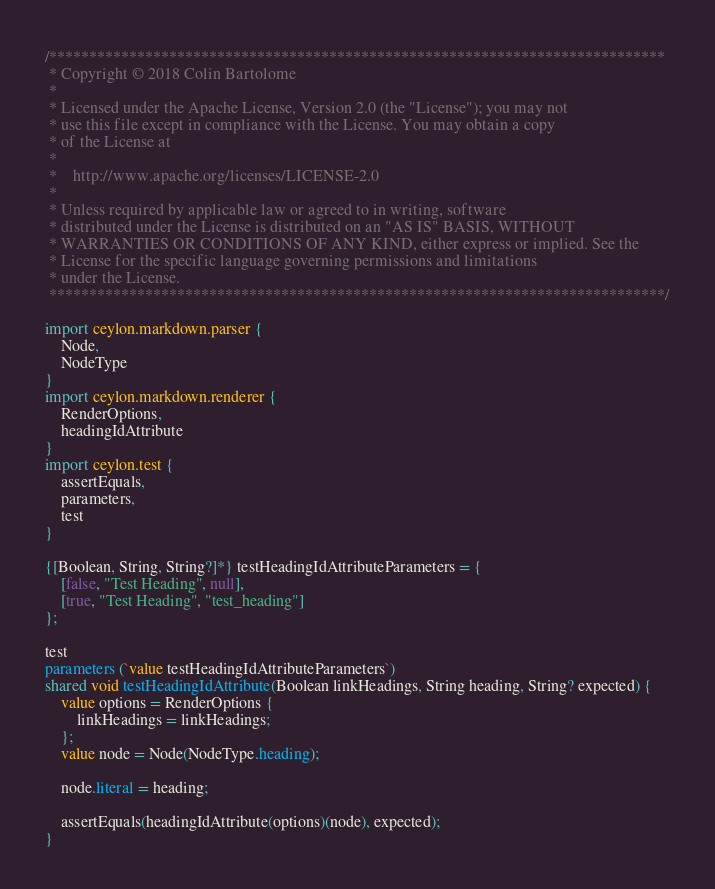Convert code to text. <code><loc_0><loc_0><loc_500><loc_500><_Ceylon_>/*****************************************************************************
 * Copyright © 2018 Colin Bartolome
 * 
 * Licensed under the Apache License, Version 2.0 (the "License"); you may not
 * use this file except in compliance with the License. You may obtain a copy
 * of the License at
 * 
 *    http://www.apache.org/licenses/LICENSE-2.0
 * 
 * Unless required by applicable law or agreed to in writing, software
 * distributed under the License is distributed on an "AS IS" BASIS, WITHOUT
 * WARRANTIES OR CONDITIONS OF ANY KIND, either express or implied. See the
 * License for the specific language governing permissions and limitations
 * under the License.
 *****************************************************************************/

import ceylon.markdown.parser {
    Node,
    NodeType
}
import ceylon.markdown.renderer {
    RenderOptions,
    headingIdAttribute
}
import ceylon.test {
    assertEquals,
    parameters,
    test
}

{[Boolean, String, String?]*} testHeadingIdAttributeParameters = {
    [false, "Test Heading", null],
    [true, "Test Heading", "test_heading"]
};

test
parameters (`value testHeadingIdAttributeParameters`)
shared void testHeadingIdAttribute(Boolean linkHeadings, String heading, String? expected) {
    value options = RenderOptions {
        linkHeadings = linkHeadings;
    };
    value node = Node(NodeType.heading);
    
    node.literal = heading;
    
    assertEquals(headingIdAttribute(options)(node), expected);
}
</code> 